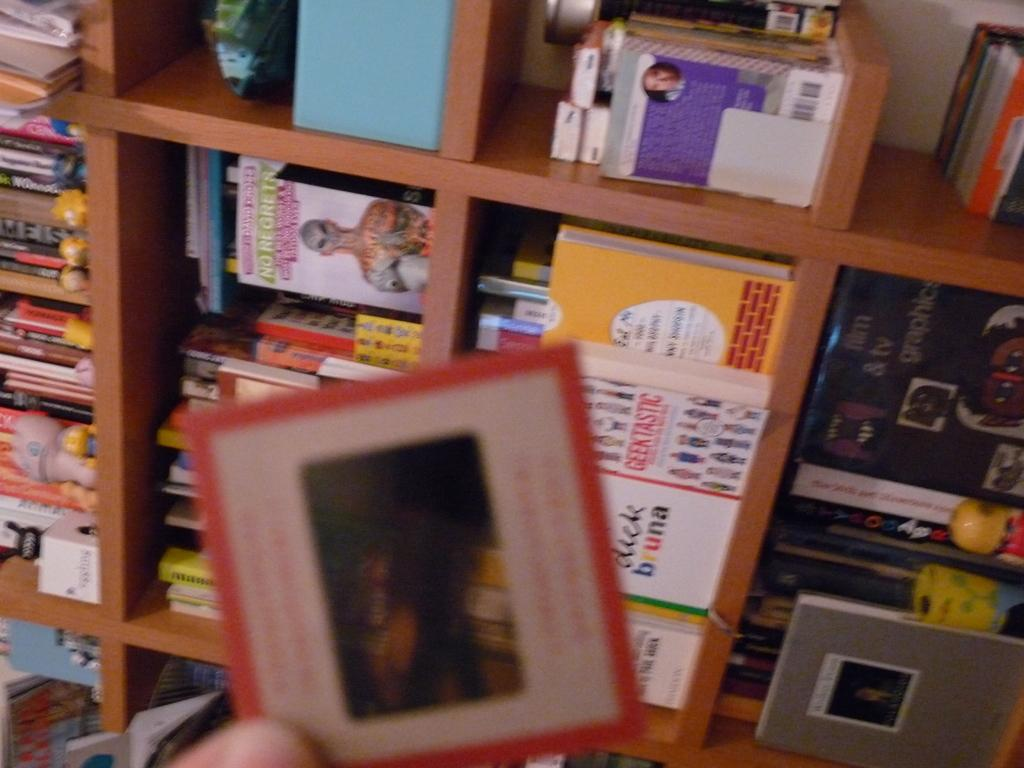What is the main subject in the foreground of the image? There is a human hand in the foreground of the image. What is the hand holding? The hand is holding a square-shaped paper-like object. What can be seen in the background of the image? There are shelves with books arranged on them in the background of the image. How many bananas are being twisted by the group in the image? There are no bananas or groups of people present in the image. 